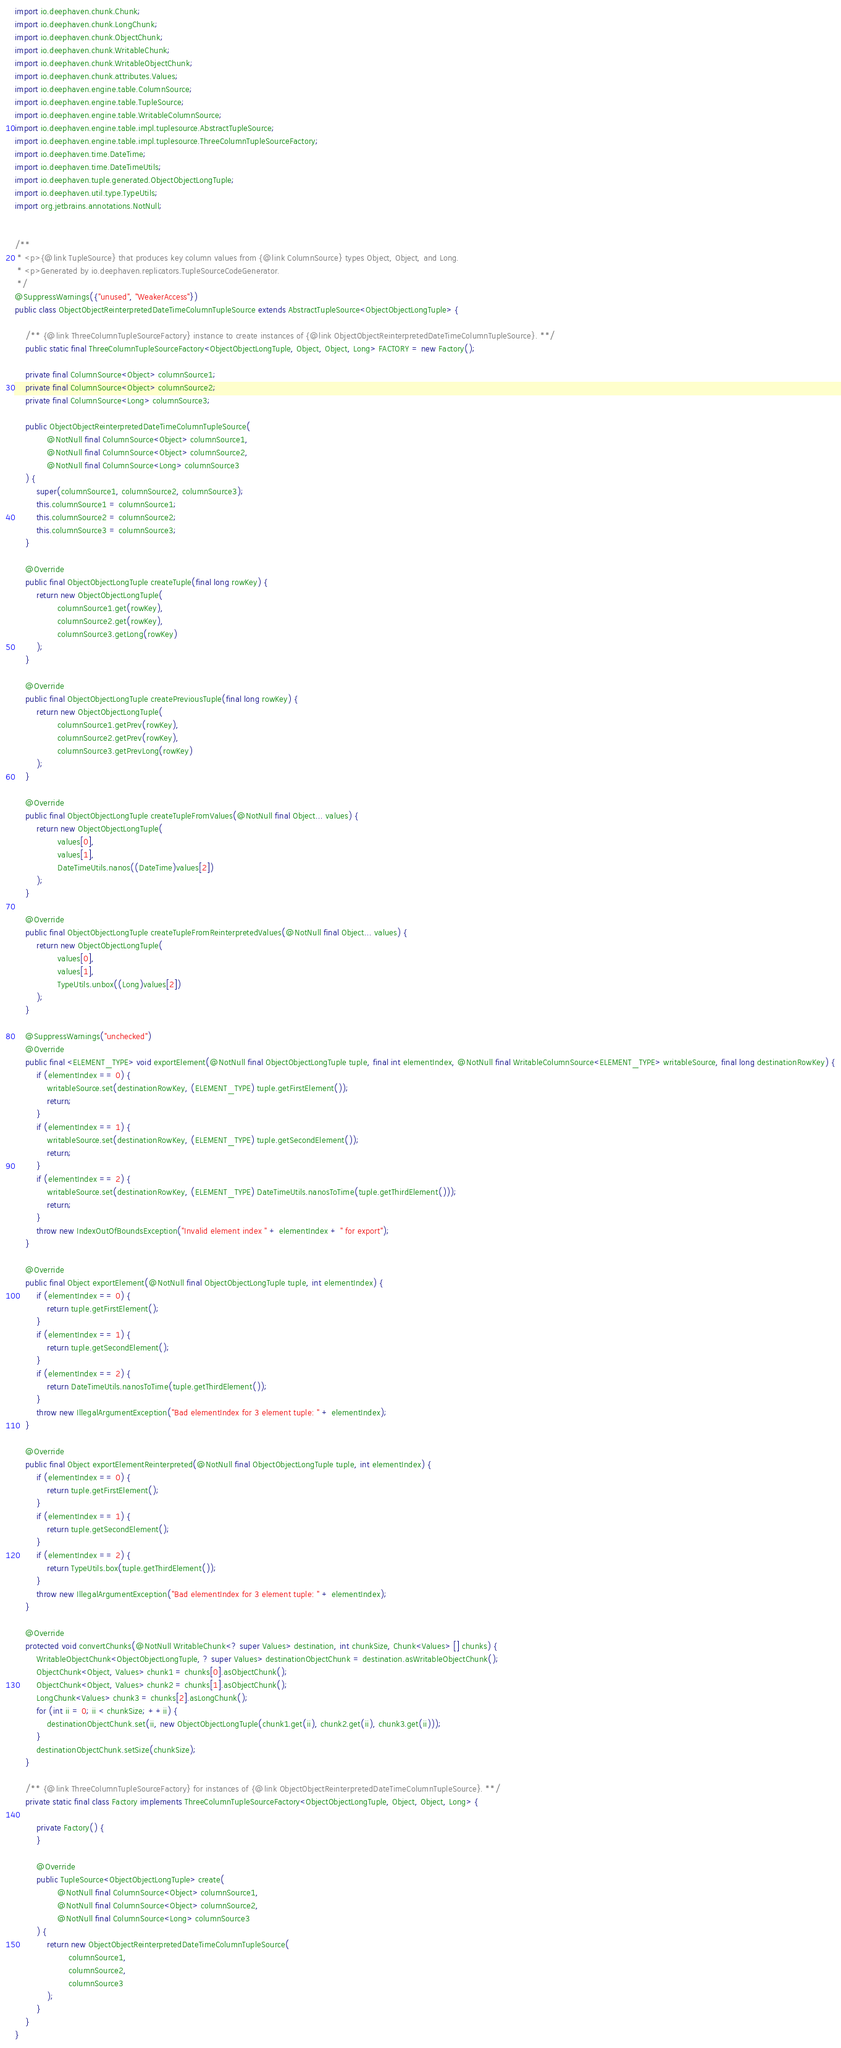<code> <loc_0><loc_0><loc_500><loc_500><_Java_>import io.deephaven.chunk.Chunk;
import io.deephaven.chunk.LongChunk;
import io.deephaven.chunk.ObjectChunk;
import io.deephaven.chunk.WritableChunk;
import io.deephaven.chunk.WritableObjectChunk;
import io.deephaven.chunk.attributes.Values;
import io.deephaven.engine.table.ColumnSource;
import io.deephaven.engine.table.TupleSource;
import io.deephaven.engine.table.WritableColumnSource;
import io.deephaven.engine.table.impl.tuplesource.AbstractTupleSource;
import io.deephaven.engine.table.impl.tuplesource.ThreeColumnTupleSourceFactory;
import io.deephaven.time.DateTime;
import io.deephaven.time.DateTimeUtils;
import io.deephaven.tuple.generated.ObjectObjectLongTuple;
import io.deephaven.util.type.TypeUtils;
import org.jetbrains.annotations.NotNull;


/**
 * <p>{@link TupleSource} that produces key column values from {@link ColumnSource} types Object, Object, and Long.
 * <p>Generated by io.deephaven.replicators.TupleSourceCodeGenerator.
 */
@SuppressWarnings({"unused", "WeakerAccess"})
public class ObjectObjectReinterpretedDateTimeColumnTupleSource extends AbstractTupleSource<ObjectObjectLongTuple> {

    /** {@link ThreeColumnTupleSourceFactory} instance to create instances of {@link ObjectObjectReinterpretedDateTimeColumnTupleSource}. **/
    public static final ThreeColumnTupleSourceFactory<ObjectObjectLongTuple, Object, Object, Long> FACTORY = new Factory();

    private final ColumnSource<Object> columnSource1;
    private final ColumnSource<Object> columnSource2;
    private final ColumnSource<Long> columnSource3;

    public ObjectObjectReinterpretedDateTimeColumnTupleSource(
            @NotNull final ColumnSource<Object> columnSource1,
            @NotNull final ColumnSource<Object> columnSource2,
            @NotNull final ColumnSource<Long> columnSource3
    ) {
        super(columnSource1, columnSource2, columnSource3);
        this.columnSource1 = columnSource1;
        this.columnSource2 = columnSource2;
        this.columnSource3 = columnSource3;
    }

    @Override
    public final ObjectObjectLongTuple createTuple(final long rowKey) {
        return new ObjectObjectLongTuple(
                columnSource1.get(rowKey),
                columnSource2.get(rowKey),
                columnSource3.getLong(rowKey)
        );
    }

    @Override
    public final ObjectObjectLongTuple createPreviousTuple(final long rowKey) {
        return new ObjectObjectLongTuple(
                columnSource1.getPrev(rowKey),
                columnSource2.getPrev(rowKey),
                columnSource3.getPrevLong(rowKey)
        );
    }

    @Override
    public final ObjectObjectLongTuple createTupleFromValues(@NotNull final Object... values) {
        return new ObjectObjectLongTuple(
                values[0],
                values[1],
                DateTimeUtils.nanos((DateTime)values[2])
        );
    }

    @Override
    public final ObjectObjectLongTuple createTupleFromReinterpretedValues(@NotNull final Object... values) {
        return new ObjectObjectLongTuple(
                values[0],
                values[1],
                TypeUtils.unbox((Long)values[2])
        );
    }

    @SuppressWarnings("unchecked")
    @Override
    public final <ELEMENT_TYPE> void exportElement(@NotNull final ObjectObjectLongTuple tuple, final int elementIndex, @NotNull final WritableColumnSource<ELEMENT_TYPE> writableSource, final long destinationRowKey) {
        if (elementIndex == 0) {
            writableSource.set(destinationRowKey, (ELEMENT_TYPE) tuple.getFirstElement());
            return;
        }
        if (elementIndex == 1) {
            writableSource.set(destinationRowKey, (ELEMENT_TYPE) tuple.getSecondElement());
            return;
        }
        if (elementIndex == 2) {
            writableSource.set(destinationRowKey, (ELEMENT_TYPE) DateTimeUtils.nanosToTime(tuple.getThirdElement()));
            return;
        }
        throw new IndexOutOfBoundsException("Invalid element index " + elementIndex + " for export");
    }

    @Override
    public final Object exportElement(@NotNull final ObjectObjectLongTuple tuple, int elementIndex) {
        if (elementIndex == 0) {
            return tuple.getFirstElement();
        }
        if (elementIndex == 1) {
            return tuple.getSecondElement();
        }
        if (elementIndex == 2) {
            return DateTimeUtils.nanosToTime(tuple.getThirdElement());
        }
        throw new IllegalArgumentException("Bad elementIndex for 3 element tuple: " + elementIndex);
    }

    @Override
    public final Object exportElementReinterpreted(@NotNull final ObjectObjectLongTuple tuple, int elementIndex) {
        if (elementIndex == 0) {
            return tuple.getFirstElement();
        }
        if (elementIndex == 1) {
            return tuple.getSecondElement();
        }
        if (elementIndex == 2) {
            return TypeUtils.box(tuple.getThirdElement());
        }
        throw new IllegalArgumentException("Bad elementIndex for 3 element tuple: " + elementIndex);
    }

    @Override
    protected void convertChunks(@NotNull WritableChunk<? super Values> destination, int chunkSize, Chunk<Values> [] chunks) {
        WritableObjectChunk<ObjectObjectLongTuple, ? super Values> destinationObjectChunk = destination.asWritableObjectChunk();
        ObjectChunk<Object, Values> chunk1 = chunks[0].asObjectChunk();
        ObjectChunk<Object, Values> chunk2 = chunks[1].asObjectChunk();
        LongChunk<Values> chunk3 = chunks[2].asLongChunk();
        for (int ii = 0; ii < chunkSize; ++ii) {
            destinationObjectChunk.set(ii, new ObjectObjectLongTuple(chunk1.get(ii), chunk2.get(ii), chunk3.get(ii)));
        }
        destinationObjectChunk.setSize(chunkSize);
    }

    /** {@link ThreeColumnTupleSourceFactory} for instances of {@link ObjectObjectReinterpretedDateTimeColumnTupleSource}. **/
    private static final class Factory implements ThreeColumnTupleSourceFactory<ObjectObjectLongTuple, Object, Object, Long> {

        private Factory() {
        }

        @Override
        public TupleSource<ObjectObjectLongTuple> create(
                @NotNull final ColumnSource<Object> columnSource1,
                @NotNull final ColumnSource<Object> columnSource2,
                @NotNull final ColumnSource<Long> columnSource3
        ) {
            return new ObjectObjectReinterpretedDateTimeColumnTupleSource(
                    columnSource1,
                    columnSource2,
                    columnSource3
            );
        }
    }
}
</code> 